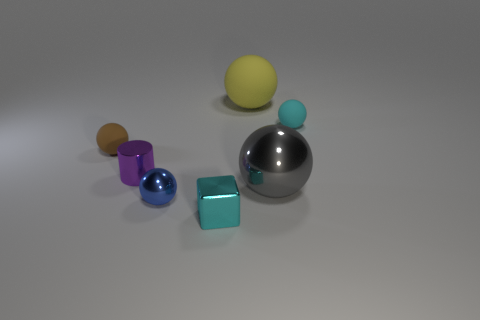The rubber object that is the same color as the small metallic cube is what shape?
Give a very brief answer. Sphere. There is a sphere that is both behind the tiny blue metal thing and in front of the brown matte thing; what is its size?
Give a very brief answer. Large. What is the color of the small metallic thing that is the same shape as the big rubber thing?
Ensure brevity in your answer.  Blue. Does the brown matte thing have the same size as the cyan rubber object?
Offer a very short reply. Yes. Is the number of small blue spheres to the right of the big gray metal object the same as the number of matte objects that are right of the purple cylinder?
Give a very brief answer. No. Is there a big shiny sphere?
Offer a terse response. Yes. There is a yellow object that is the same shape as the big gray object; what size is it?
Provide a short and direct response. Large. What is the size of the shiny object that is right of the cyan metal object?
Provide a short and direct response. Large. Is the number of small rubber objects that are on the left side of the gray ball greater than the number of small green shiny balls?
Give a very brief answer. Yes. What is the shape of the blue thing?
Offer a terse response. Sphere. 